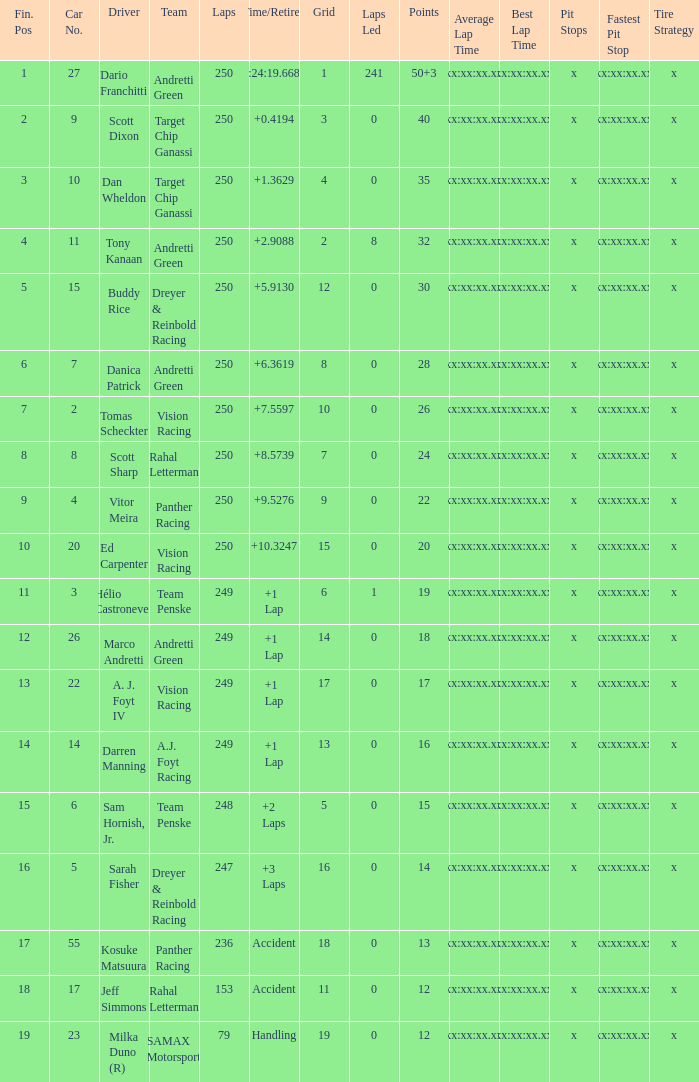Name the least grid for 17 points  17.0. Would you be able to parse every entry in this table? {'header': ['Fin. Pos', 'Car No.', 'Driver', 'Team', 'Laps', 'Time/Retired', 'Grid', 'Laps Led', 'Points', 'Average Lap Time', 'Best Lap Time', 'Pit Stops', 'Fastest Pit Stop', 'Tire Strategy'], 'rows': [['1', '27', 'Dario Franchitti', 'Andretti Green', '250', '1:24:19.6684', '1', '241', '50+3', 'xx:xx:xx.xx', 'xx:xx:xx.xx', 'x', 'xx:xx:xx.xx', 'x'], ['2', '9', 'Scott Dixon', 'Target Chip Ganassi', '250', '+0.4194', '3', '0', '40', 'xx:xx:xx.xx', 'xx:xx:xx.xx', 'x', 'xx:xx:xx.xx', 'x'], ['3', '10', 'Dan Wheldon', 'Target Chip Ganassi', '250', '+1.3629', '4', '0', '35', 'xx:xx:xx.xx', 'xx:xx:xx.xx', 'x', 'xx:xx:xx.xx', 'x'], ['4', '11', 'Tony Kanaan', 'Andretti Green', '250', '+2.9088', '2', '8', '32', 'xx:xx:xx.xx', 'xx:xx:xx.xx', 'x', 'xx:xx:xx.xx', 'x'], ['5', '15', 'Buddy Rice', 'Dreyer & Reinbold Racing', '250', '+5.9130', '12', '0', '30', 'xx:xx:xx.xx', 'xx:xx:xx.xx', 'x', 'xx:xx:xx.xx', 'x'], ['6', '7', 'Danica Patrick', 'Andretti Green', '250', '+6.3619', '8', '0', '28', 'xx:xx:xx.xx', 'xx:xx:xx.xx', 'x', 'xx:xx:xx.xx', 'x'], ['7', '2', 'Tomas Scheckter', 'Vision Racing', '250', '+7.5597', '10', '0', '26', 'xx:xx:xx.xx', 'xx:xx:xx.xx', 'x', 'xx:xx:xx.xx', 'x'], ['8', '8', 'Scott Sharp', 'Rahal Letterman', '250', '+8.5739', '7', '0', '24', 'xx:xx:xx.xx', 'xx:xx:xx.xx', 'x', 'xx:xx:xx.xx', 'x'], ['9', '4', 'Vitor Meira', 'Panther Racing', '250', '+9.5276', '9', '0', '22', 'xx:xx:xx.xx', 'xx:xx:xx.xx', 'x', 'xx:xx:xx.xx', 'x'], ['10', '20', 'Ed Carpenter', 'Vision Racing', '250', '+10.3247', '15', '0', '20', 'xx:xx:xx.xx', 'xx:xx:xx.xx', 'x', 'xx:xx:xx.xx', 'x'], ['11', '3', 'Hélio Castroneves', 'Team Penske', '249', '+1 Lap', '6', '1', '19', 'xx:xx:xx.xx', 'xx:xx:xx.xx', 'x', 'xx:xx:xx.xx', 'x'], ['12', '26', 'Marco Andretti', 'Andretti Green', '249', '+1 Lap', '14', '0', '18', 'xx:xx:xx.xx', 'xx:xx:xx.xx', 'x', 'xx:xx:xx.xx', 'x'], ['13', '22', 'A. J. Foyt IV', 'Vision Racing', '249', '+1 Lap', '17', '0', '17', 'xx:xx:xx.xx', 'xx:xx:xx.xx', 'x', 'xx:xx:xx.xx', 'x'], ['14', '14', 'Darren Manning', 'A.J. Foyt Racing', '249', '+1 Lap', '13', '0', '16', 'xx:xx:xx.xx', 'xx:xx:xx.xx', 'x', 'xx:xx:xx.xx', 'x'], ['15', '6', 'Sam Hornish, Jr.', 'Team Penske', '248', '+2 Laps', '5', '0', '15', 'xx:xx:xx.xx', 'xx:xx:xx.xx', 'x', 'xx:xx:xx.xx', 'x'], ['16', '5', 'Sarah Fisher', 'Dreyer & Reinbold Racing', '247', '+3 Laps', '16', '0', '14', 'xx:xx:xx.xx', 'xx:xx:xx.xx', 'x', 'xx:xx:xx.xx', 'x'], ['17', '55', 'Kosuke Matsuura', 'Panther Racing', '236', 'Accident', '18', '0', '13', 'xx:xx:xx.xx', 'xx:xx:xx.xx', 'x', 'xx:xx:xx.xx', 'x'], ['18', '17', 'Jeff Simmons', 'Rahal Letterman', '153', 'Accident', '11', '0', '12', 'xx:xx:xx.xx', 'xx:xx:xx.xx', 'x', 'xx:xx:xx.xx', 'x'], ['19', '23', 'Milka Duno (R)', 'SAMAX Motorsport', '79', 'Handling', '19', '0', '12', 'xx:xx:xx.xx', 'xx:xx:xx.xx', 'x', 'xx:xx:xx.xx', 'x']]} 